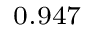Convert formula to latex. <formula><loc_0><loc_0><loc_500><loc_500>_ { 0 . 9 4 7 }</formula> 